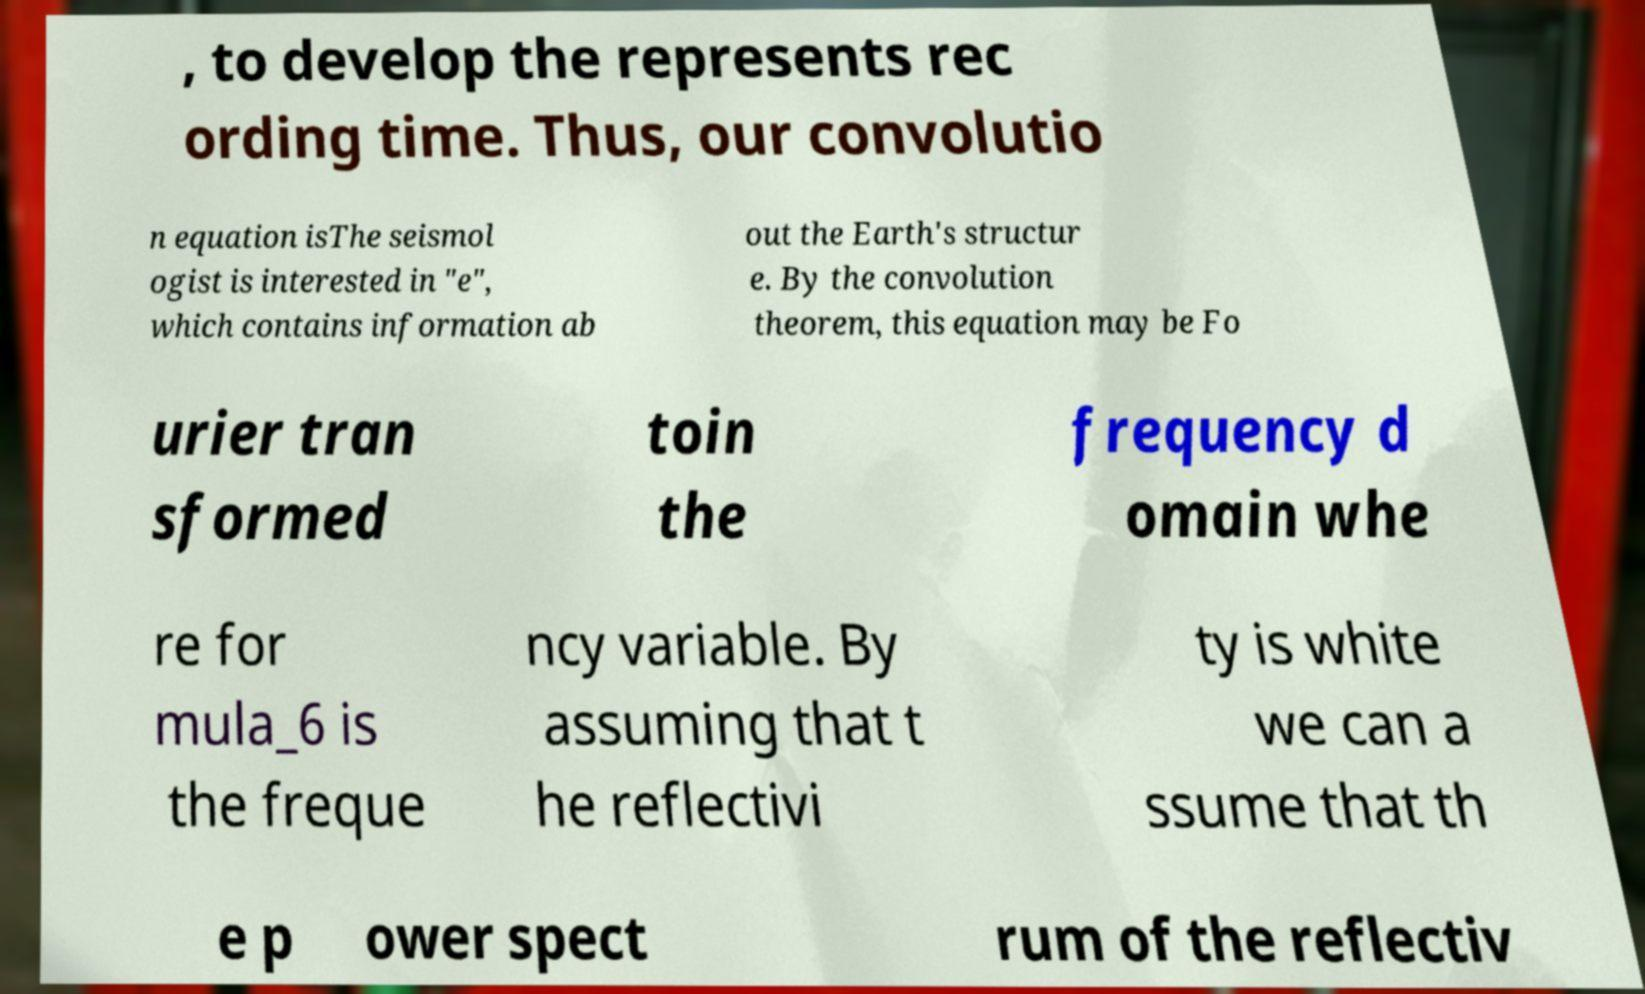For documentation purposes, I need the text within this image transcribed. Could you provide that? , to develop the represents rec ording time. Thus, our convolutio n equation isThe seismol ogist is interested in "e", which contains information ab out the Earth's structur e. By the convolution theorem, this equation may be Fo urier tran sformed toin the frequency d omain whe re for mula_6 is the freque ncy variable. By assuming that t he reflectivi ty is white we can a ssume that th e p ower spect rum of the reflectiv 